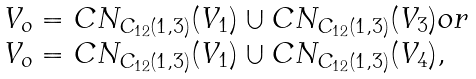Convert formula to latex. <formula><loc_0><loc_0><loc_500><loc_500>\begin{array} { l l } V _ { o } = C N _ { C _ { 1 2 } ( 1 , 3 ) } ( V _ { 1 } ) \cup C N _ { C _ { 1 2 } ( 1 , 3 ) } ( V _ { 3 } ) o r \\ V _ { o } = C N _ { C _ { 1 2 } ( 1 , 3 ) } ( V _ { 1 } ) \cup C N _ { C _ { 1 2 } ( 1 , 3 ) } ( V _ { 4 } ) , \end{array}</formula> 